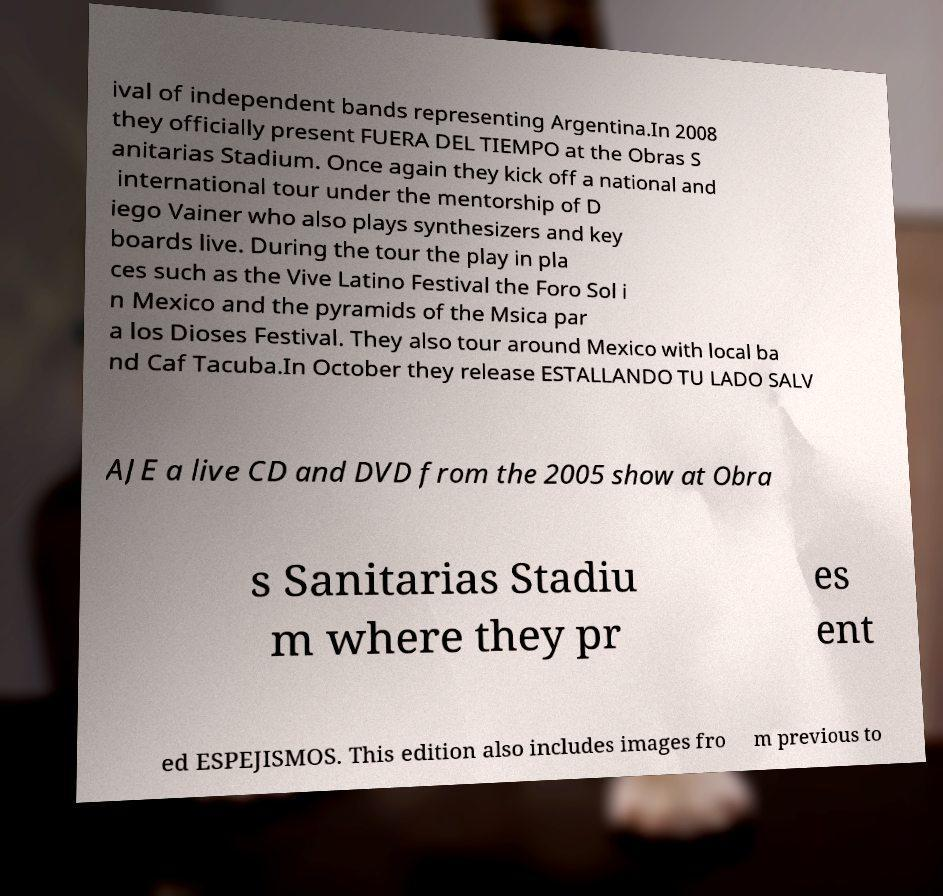Please read and relay the text visible in this image. What does it say? ival of independent bands representing Argentina.In 2008 they officially present FUERA DEL TIEMPO at the Obras S anitarias Stadium. Once again they kick off a national and international tour under the mentorship of D iego Vainer who also plays synthesizers and key boards live. During the tour the play in pla ces such as the Vive Latino Festival the Foro Sol i n Mexico and the pyramids of the Msica par a los Dioses Festival. They also tour around Mexico with local ba nd Caf Tacuba.In October they release ESTALLANDO TU LADO SALV AJE a live CD and DVD from the 2005 show at Obra s Sanitarias Stadiu m where they pr es ent ed ESPEJISMOS. This edition also includes images fro m previous to 